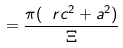<formula> <loc_0><loc_0><loc_500><loc_500>= \frac { \pi ( \ r c ^ { 2 } + a ^ { 2 } ) } { \Xi }</formula> 